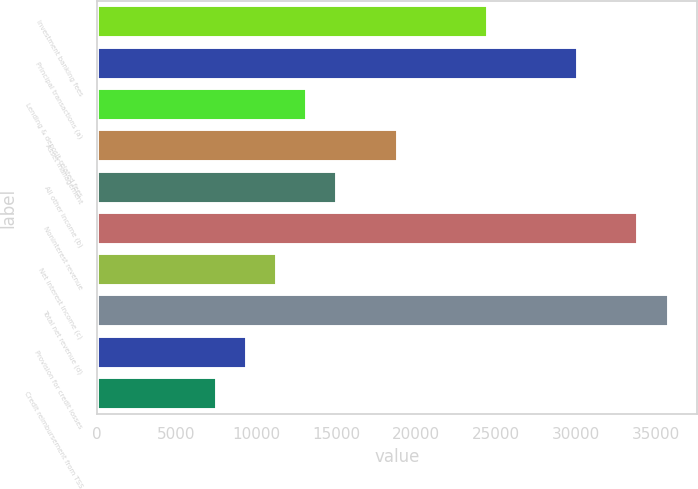Convert chart to OTSL. <chart><loc_0><loc_0><loc_500><loc_500><bar_chart><fcel>Investment banking fees<fcel>Principal transactions (a)<fcel>Lending & deposit-related fees<fcel>Asset management<fcel>All other income (b)<fcel>Noninterest revenue<fcel>Net interest income (c)<fcel>Total net revenue (d)<fcel>Provision for credit losses<fcel>Credit reimbursement from TSS<nl><fcel>24482.7<fcel>30132.4<fcel>13183.2<fcel>18833<fcel>15066.5<fcel>33898.9<fcel>11300<fcel>35782.1<fcel>9416.77<fcel>7533.53<nl></chart> 